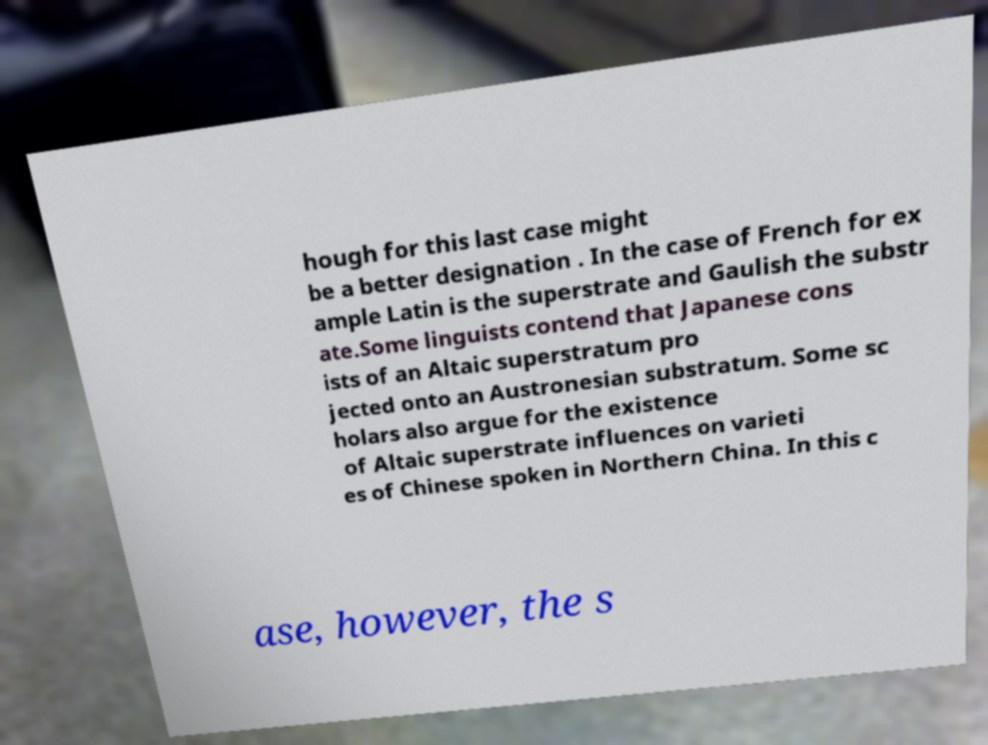What messages or text are displayed in this image? I need them in a readable, typed format. hough for this last case might be a better designation . In the case of French for ex ample Latin is the superstrate and Gaulish the substr ate.Some linguists contend that Japanese cons ists of an Altaic superstratum pro jected onto an Austronesian substratum. Some sc holars also argue for the existence of Altaic superstrate influences on varieti es of Chinese spoken in Northern China. In this c ase, however, the s 